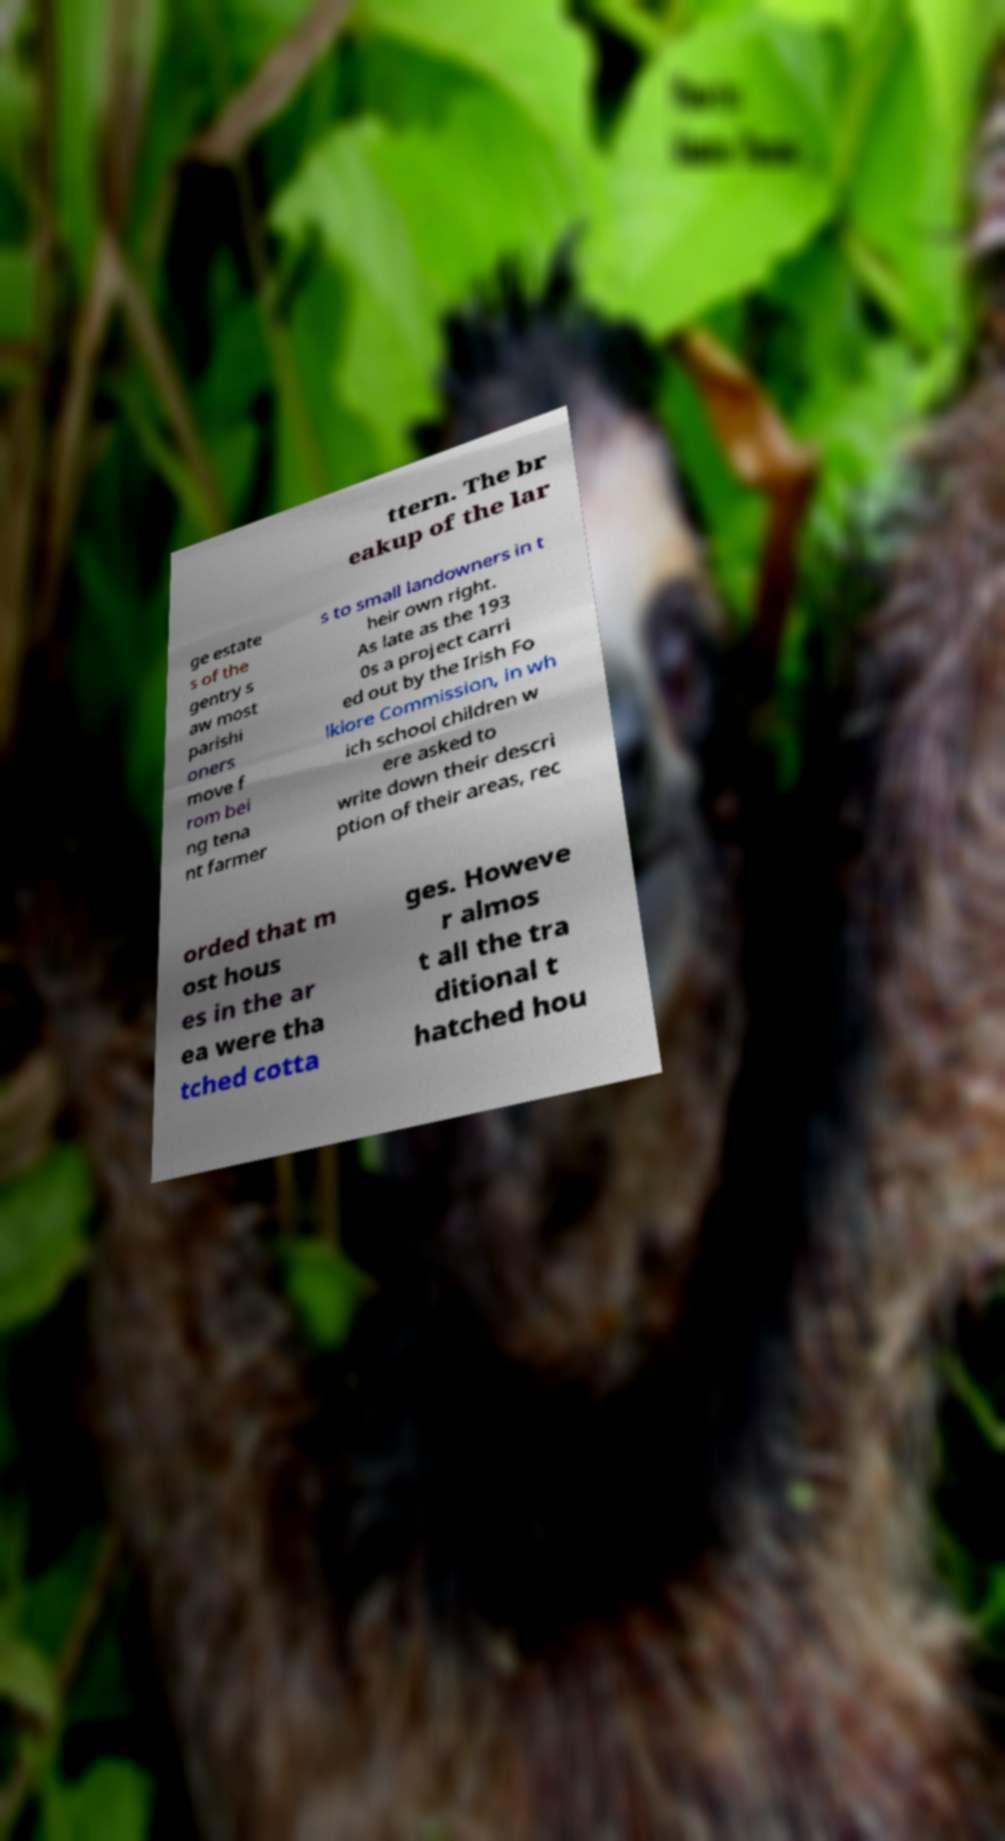Can you accurately transcribe the text from the provided image for me? ttern. The br eakup of the lar ge estate s of the gentry s aw most parishi oners move f rom bei ng tena nt farmer s to small landowners in t heir own right. As late as the 193 0s a project carri ed out by the Irish Fo lklore Commission, in wh ich school children w ere asked to write down their descri ption of their areas, rec orded that m ost hous es in the ar ea were tha tched cotta ges. Howeve r almos t all the tra ditional t hatched hou 